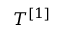Convert formula to latex. <formula><loc_0><loc_0><loc_500><loc_500>T ^ { [ 1 ] }</formula> 